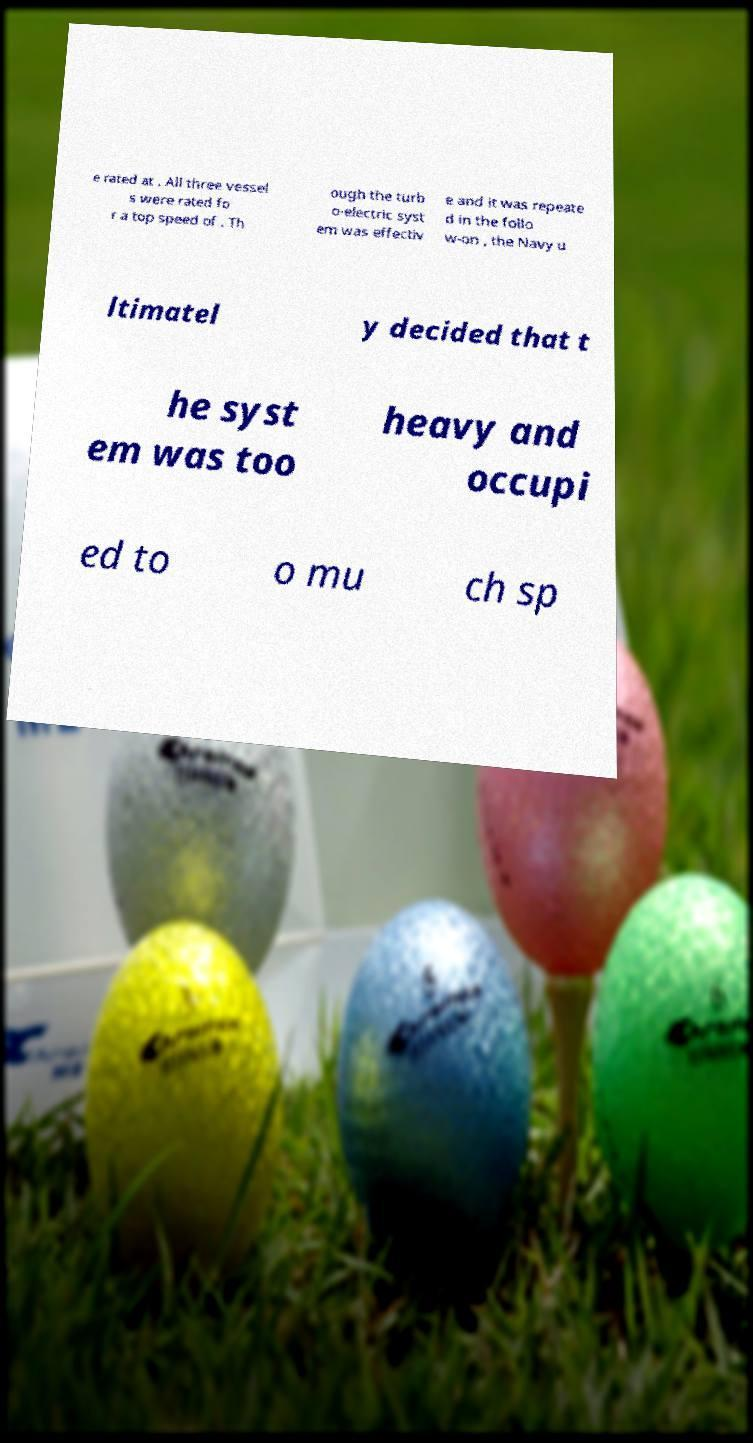Could you extract and type out the text from this image? e rated at . All three vessel s were rated fo r a top speed of . Th ough the turb o-electric syst em was effectiv e and it was repeate d in the follo w-on , the Navy u ltimatel y decided that t he syst em was too heavy and occupi ed to o mu ch sp 